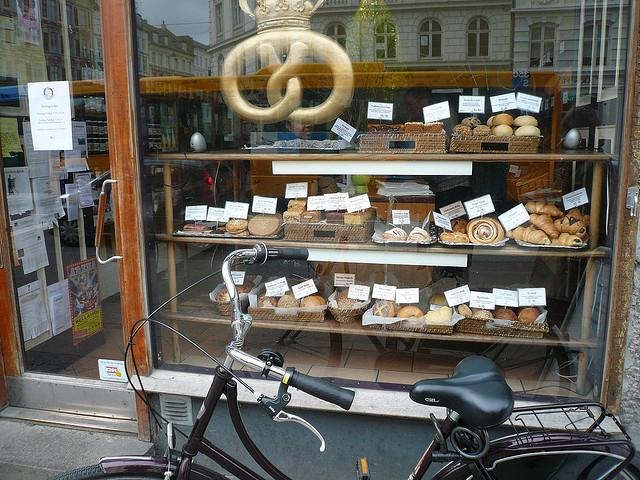What color is painted on the metal frame of the bicycle parked in front of the cake store? Please explain your reasoning. black. A dark colored bike is parked in front of a store with pastries in the window. bakeries that make cake often advertise pastries and baked goods in their windows. 